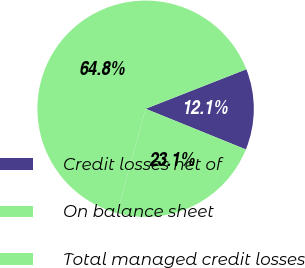<chart> <loc_0><loc_0><loc_500><loc_500><pie_chart><fcel>Credit losses net of<fcel>On balance sheet<fcel>Total managed credit losses<nl><fcel>12.09%<fcel>23.11%<fcel>64.81%<nl></chart> 